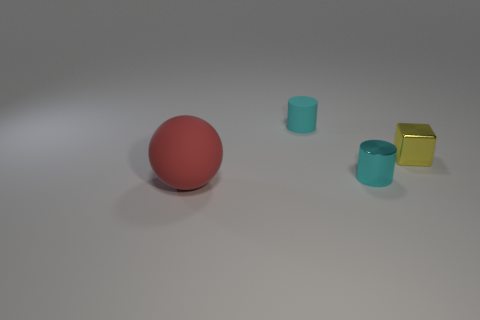Add 3 small yellow balls. How many objects exist? 7 Subtract 0 brown spheres. How many objects are left? 4 Subtract all balls. How many objects are left? 3 Subtract all green cylinders. Subtract all blue spheres. How many cylinders are left? 2 Subtract all red spheres. Subtract all yellow rubber cubes. How many objects are left? 3 Add 3 red objects. How many red objects are left? 4 Add 1 matte balls. How many matte balls exist? 2 